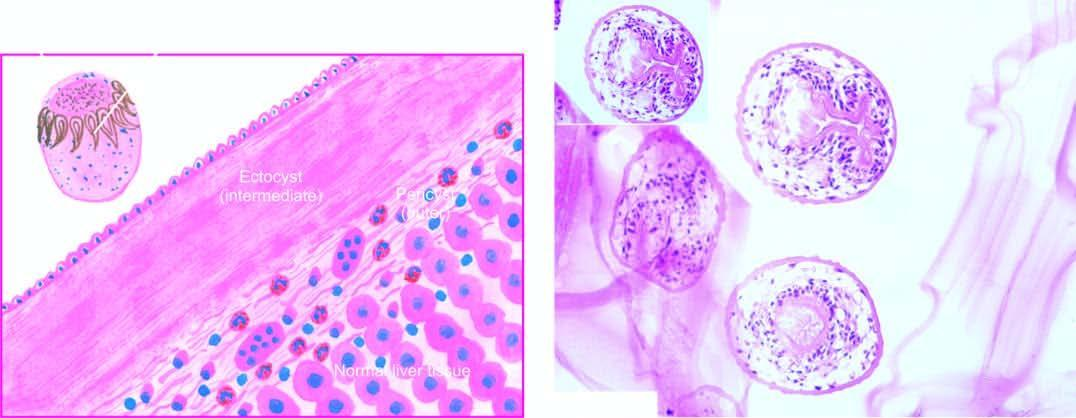does inbox in the right photomicrograph show a scolex with a row of hooklets?
Answer the question using a single word or phrase. Yes 